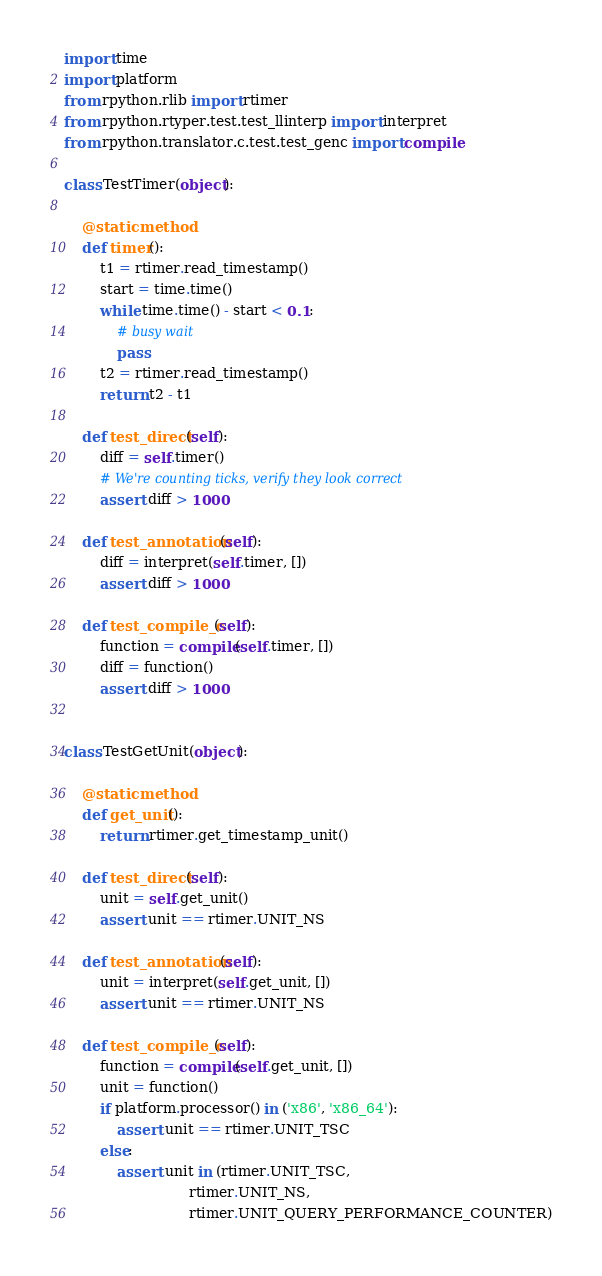Convert code to text. <code><loc_0><loc_0><loc_500><loc_500><_Python_>import time
import platform
from rpython.rlib import rtimer
from rpython.rtyper.test.test_llinterp import interpret
from rpython.translator.c.test.test_genc import compile

class TestTimer(object):

    @staticmethod
    def timer():
        t1 = rtimer.read_timestamp()
        start = time.time()
        while time.time() - start < 0.1:
            # busy wait
            pass
        t2 = rtimer.read_timestamp()
        return t2 - t1

    def test_direct(self):
        diff = self.timer()
        # We're counting ticks, verify they look correct
        assert diff > 1000

    def test_annotation(self):
        diff = interpret(self.timer, [])
        assert diff > 1000

    def test_compile_c(self):
        function = compile(self.timer, [])
        diff = function()
        assert diff > 1000


class TestGetUnit(object):

    @staticmethod
    def get_unit():
        return rtimer.get_timestamp_unit()

    def test_direct(self):
        unit = self.get_unit()
        assert unit == rtimer.UNIT_NS

    def test_annotation(self):
        unit = interpret(self.get_unit, [])
        assert unit == rtimer.UNIT_NS

    def test_compile_c(self):
        function = compile(self.get_unit, [])
        unit = function()
        if platform.processor() in ('x86', 'x86_64'):
            assert unit == rtimer.UNIT_TSC
        else:
            assert unit in (rtimer.UNIT_TSC,
                            rtimer.UNIT_NS,
                            rtimer.UNIT_QUERY_PERFORMANCE_COUNTER)
</code> 